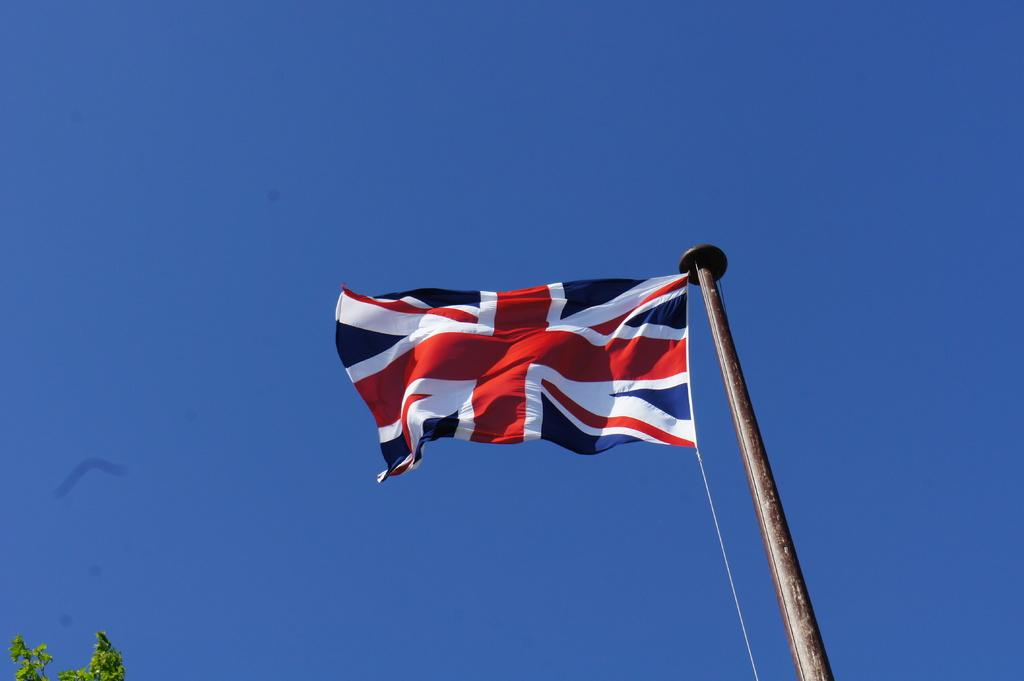What is the main object in the image? There is a flag in the image. How is the flag supported? The flag is on a pole. Is there any additional equipment associated with the flag? Yes, there is a rope associated with the flag. What type of natural element can be seen in the image? There is a tree in the bottom left of the image. What is visible at the top of the image? The sky is visible at the top of the image. What type of baseball game is being played in the image? There is no baseball game present in the image; it features a flag on a pole with a rope. What type of quilt is draped over the tree in the image? There is no quilt present in the image; it features a tree and a flag on a pole with a rope. 